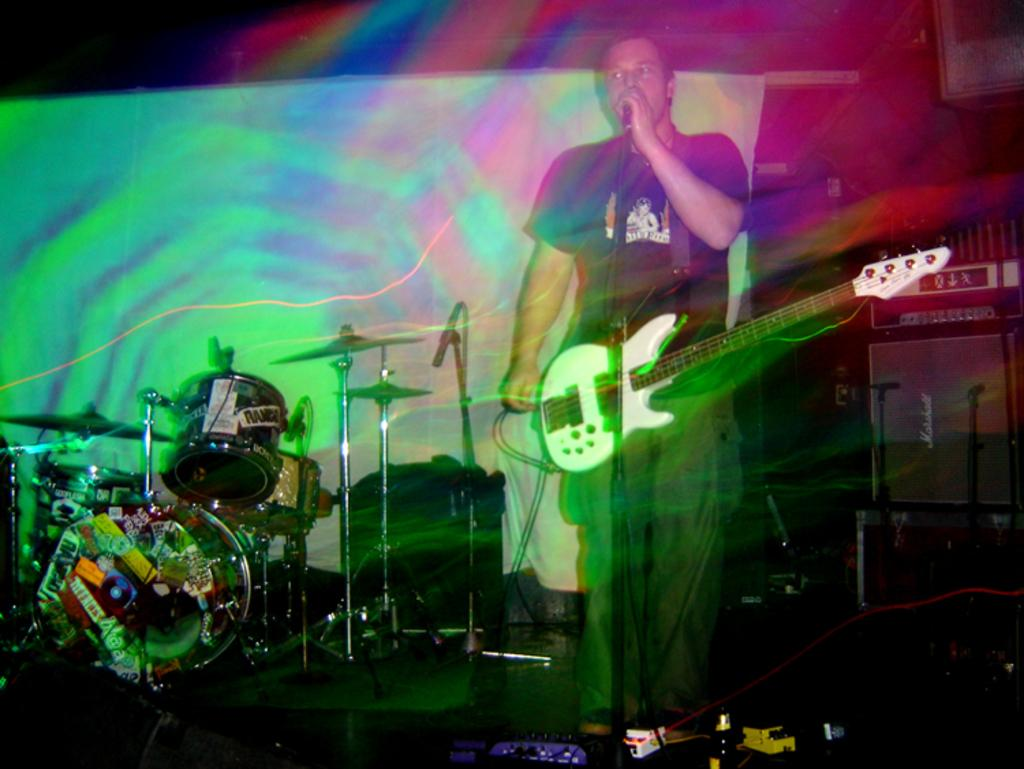What is the person on the right side of the image doing? The person is standing on the right side of the image and is holding a guitar. What activity is the person engaged in? The person is singing into a microphone. What other musical instrument can be seen on the stage in the image? There is a drum kit on the stage in the image. What is present at the back of the stage? There is a curtain at the back of the stage. What type of dinner is being prepared on the stage in the image? There is no dinner being prepared on the stage in the image; it is a performance setting with a person singing and playing a guitar, a drum kit, and a curtain at the back of the stage. 